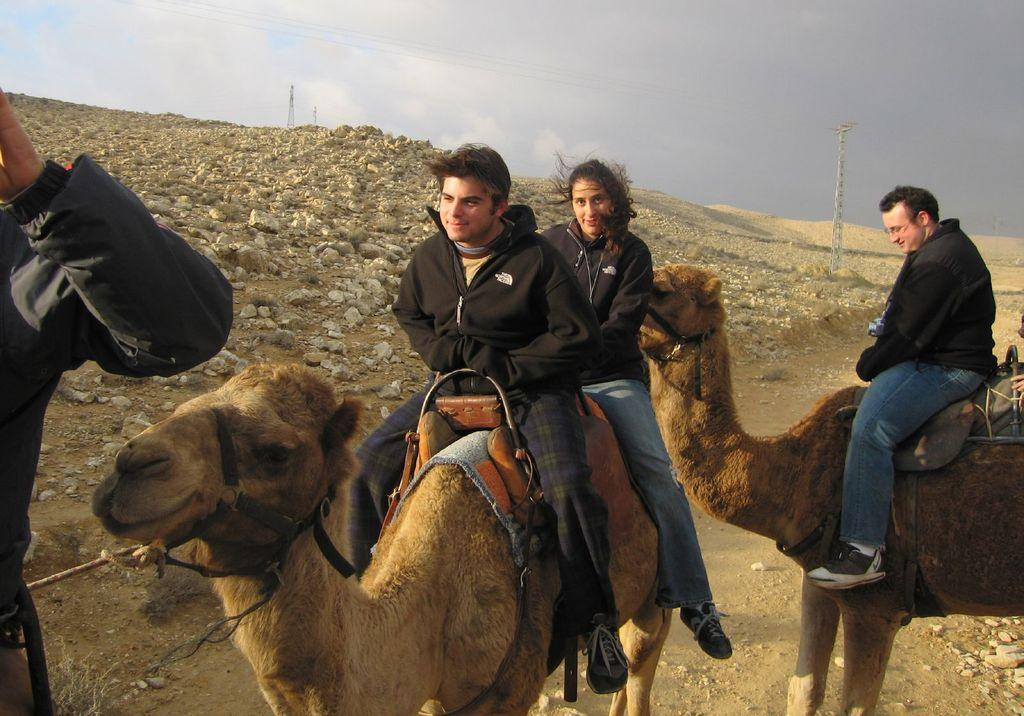What are the people in the image riding? The people in the image are sitting on camels. What can be seen in the background of the image? The sky is visible in the background of the image. How many shoes are visible in the image? There are no shoes visible in the image; the people are sitting on camels. What type of animal is present in the image, besides the camels? There are no other animals besides the camels present in the image. 